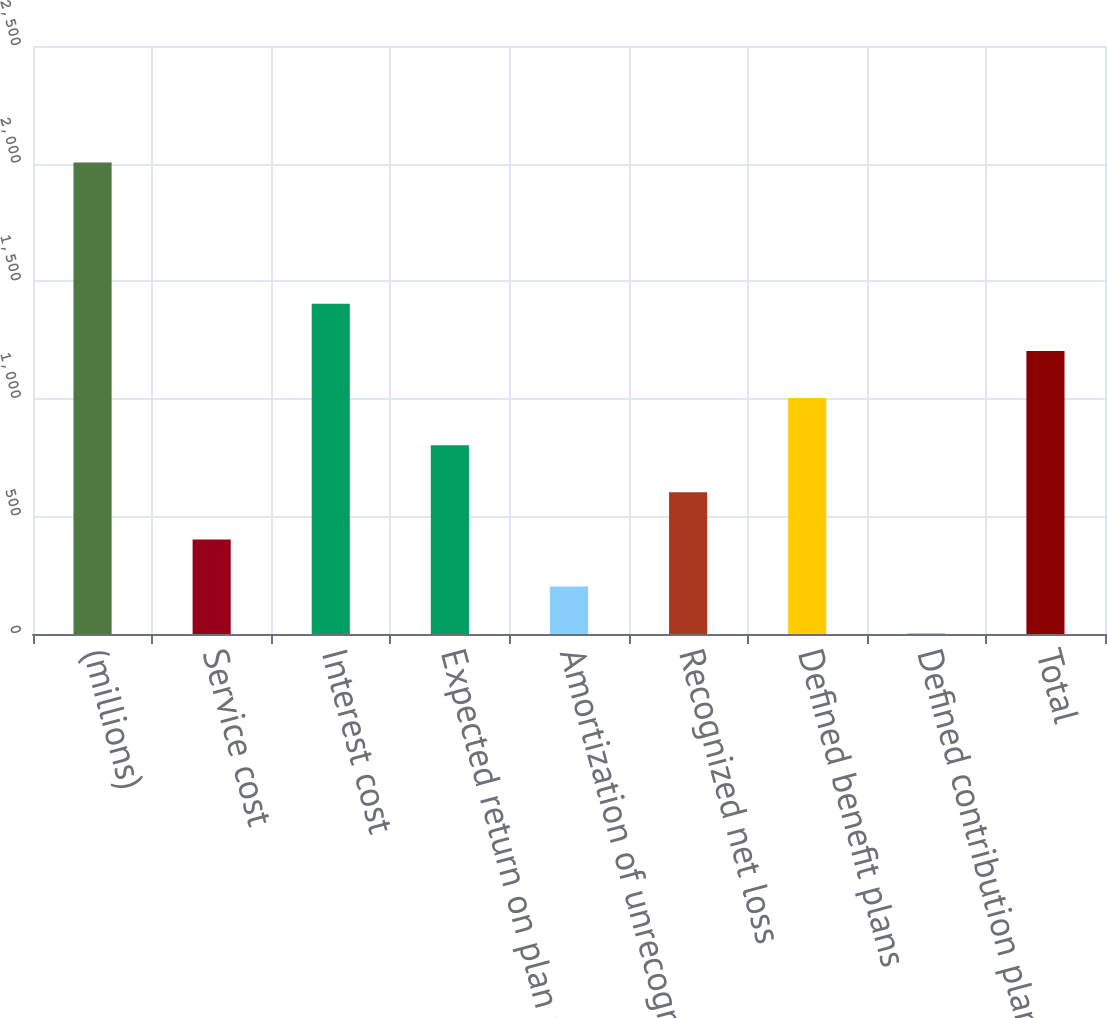Convert chart to OTSL. <chart><loc_0><loc_0><loc_500><loc_500><bar_chart><fcel>(millions)<fcel>Service cost<fcel>Interest cost<fcel>Expected return on plan assets<fcel>Amortization of unrecognized<fcel>Recognized net loss<fcel>Defined benefit plans<fcel>Defined contribution plans<fcel>Total<nl><fcel>2005<fcel>402.04<fcel>1403.89<fcel>802.78<fcel>201.67<fcel>602.41<fcel>1003.15<fcel>1.3<fcel>1203.52<nl></chart> 